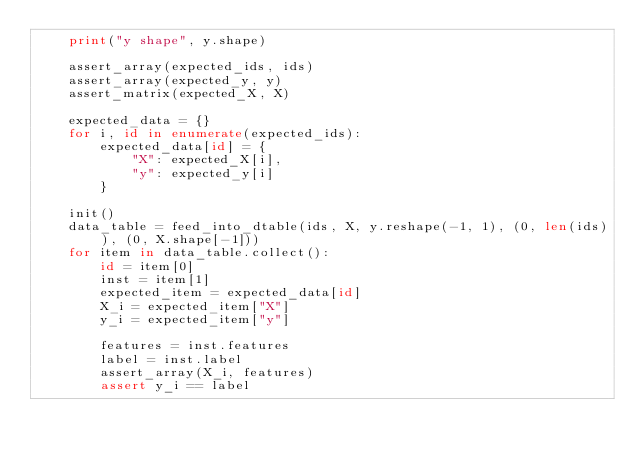Convert code to text. <code><loc_0><loc_0><loc_500><loc_500><_Python_>    print("y shape", y.shape)

    assert_array(expected_ids, ids)
    assert_array(expected_y, y)
    assert_matrix(expected_X, X)

    expected_data = {}
    for i, id in enumerate(expected_ids):
        expected_data[id] = {
            "X": expected_X[i],
            "y": expected_y[i]
        }

    init()
    data_table = feed_into_dtable(ids, X, y.reshape(-1, 1), (0, len(ids)), (0, X.shape[-1]))
    for item in data_table.collect():
        id = item[0]
        inst = item[1]
        expected_item = expected_data[id]
        X_i = expected_item["X"]
        y_i = expected_item["y"]

        features = inst.features
        label = inst.label
        assert_array(X_i, features)
        assert y_i == label
</code> 